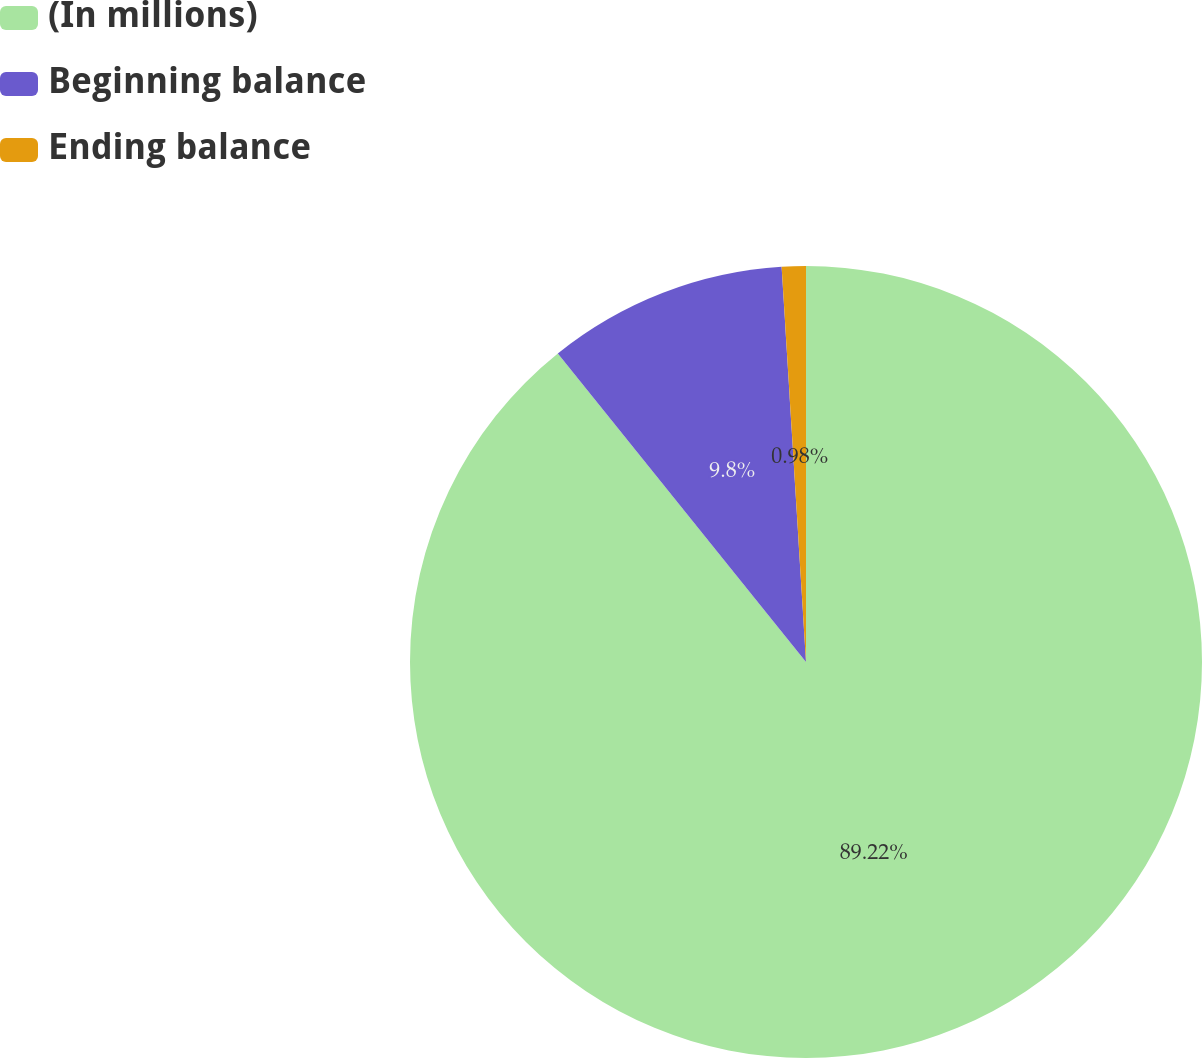Convert chart. <chart><loc_0><loc_0><loc_500><loc_500><pie_chart><fcel>(In millions)<fcel>Beginning balance<fcel>Ending balance<nl><fcel>89.22%<fcel>9.8%<fcel>0.98%<nl></chart> 